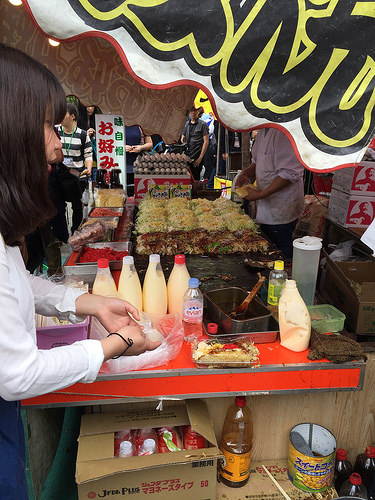<image>
Is the counter to the left of the bottle? No. The counter is not to the left of the bottle. From this viewpoint, they have a different horizontal relationship. 